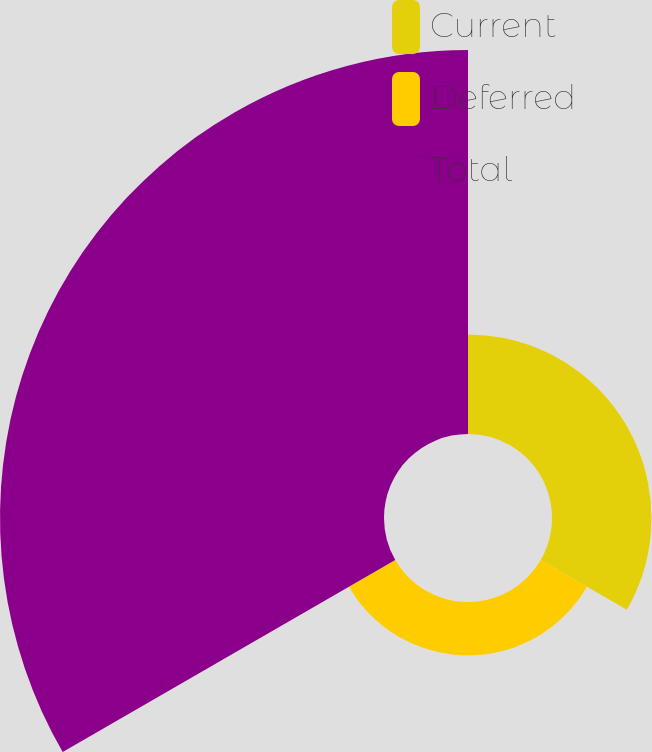Convert chart to OTSL. <chart><loc_0><loc_0><loc_500><loc_500><pie_chart><fcel>Current<fcel>Deferred<fcel>Total<nl><fcel>18.52%<fcel>9.95%<fcel>71.54%<nl></chart> 